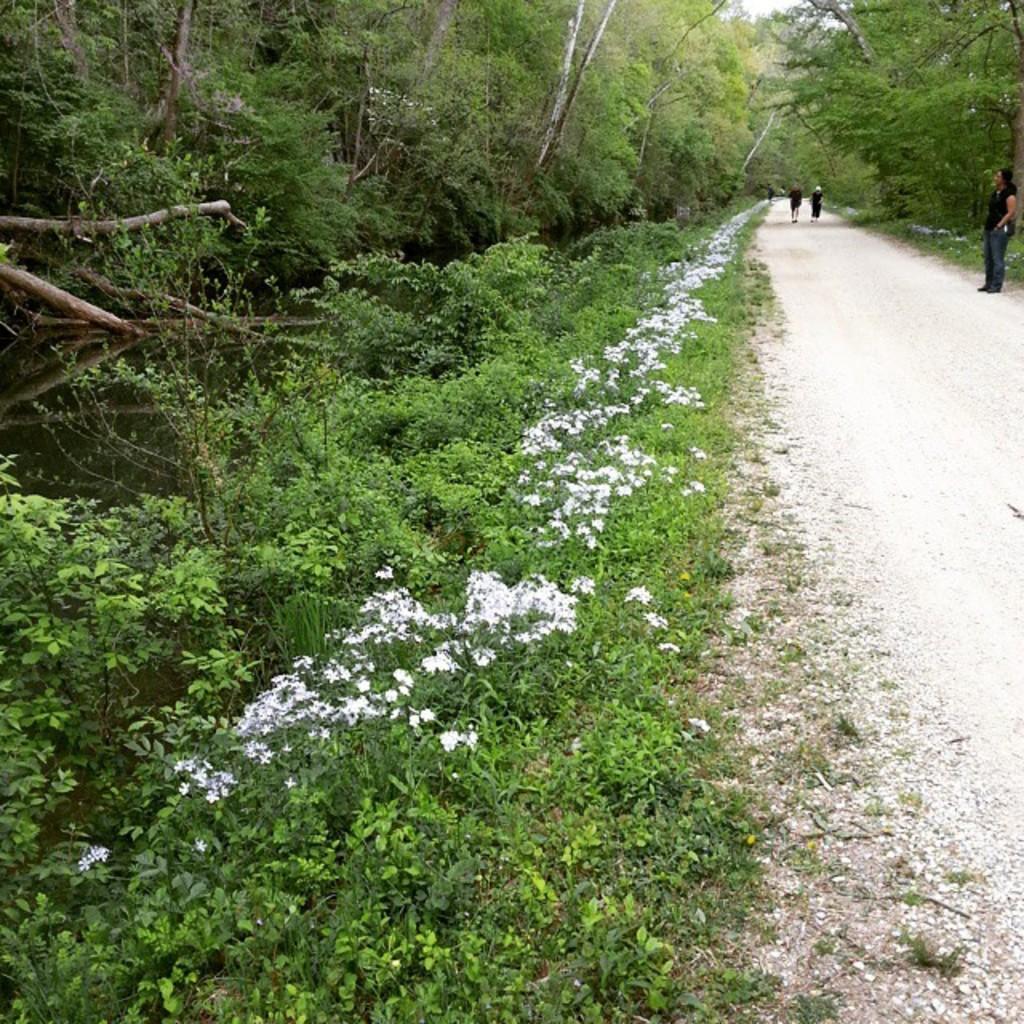Please provide a concise description of this image. This is an outside view. On the right side there is a person standing on the road and two persons are running. Beside the road there are many flower plants and trees. 